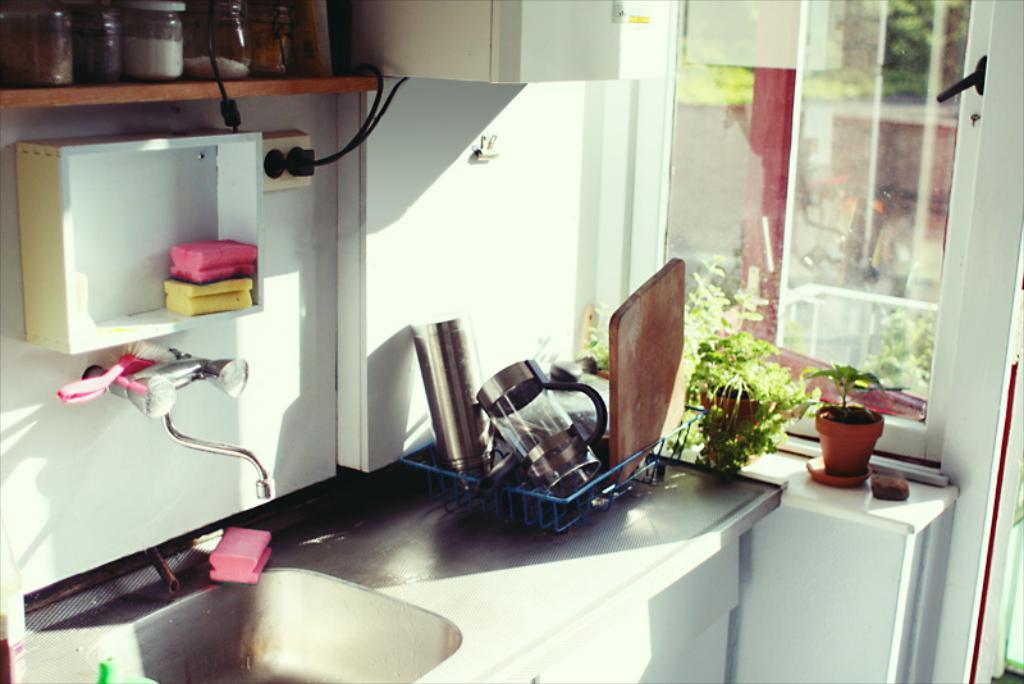In one or two sentences, can you explain what this image depicts? In this image we can see the inner view of a kitchen. In the kitchen there are sink, tap, pet jars, electric cables, utensils in the stand, house plants and detergent soaps. 